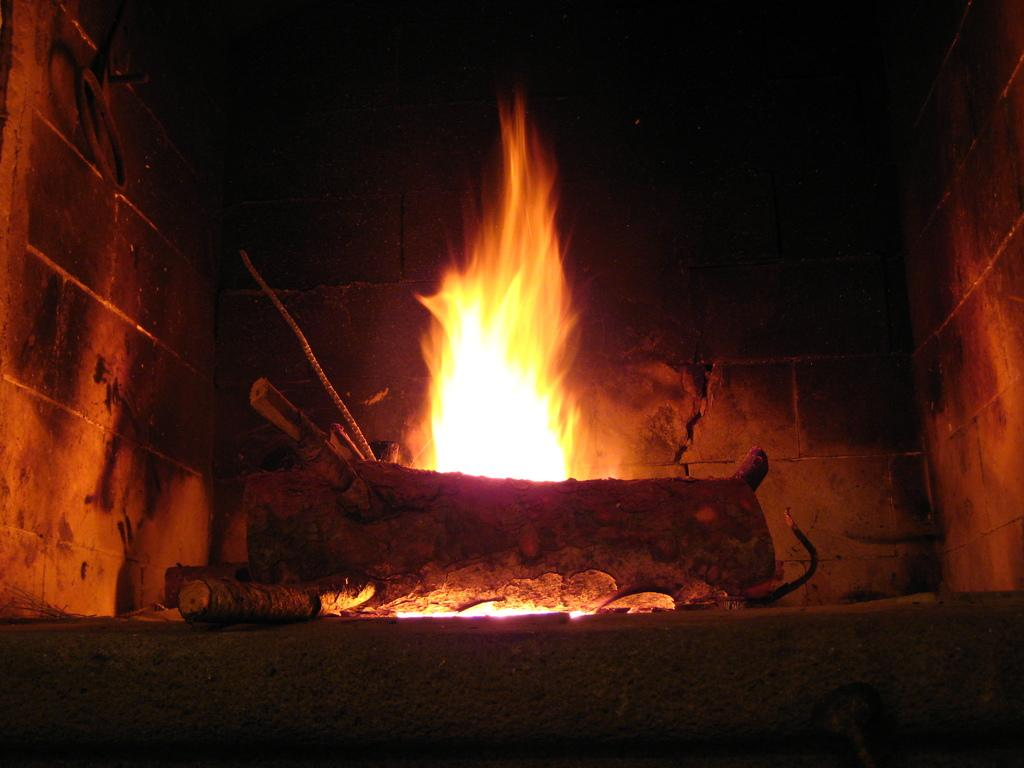What is the main feature in the center of the image? There is a fireplace in the center of the image. What is inside the fireplace? There are logs in the fireplace. What can be seen in the background of the image? There is a wall in the background of the image. What type of bait is being used to catch fish in the image? There is no mention of fish or bait in the image; it features a fireplace with logs inside. 